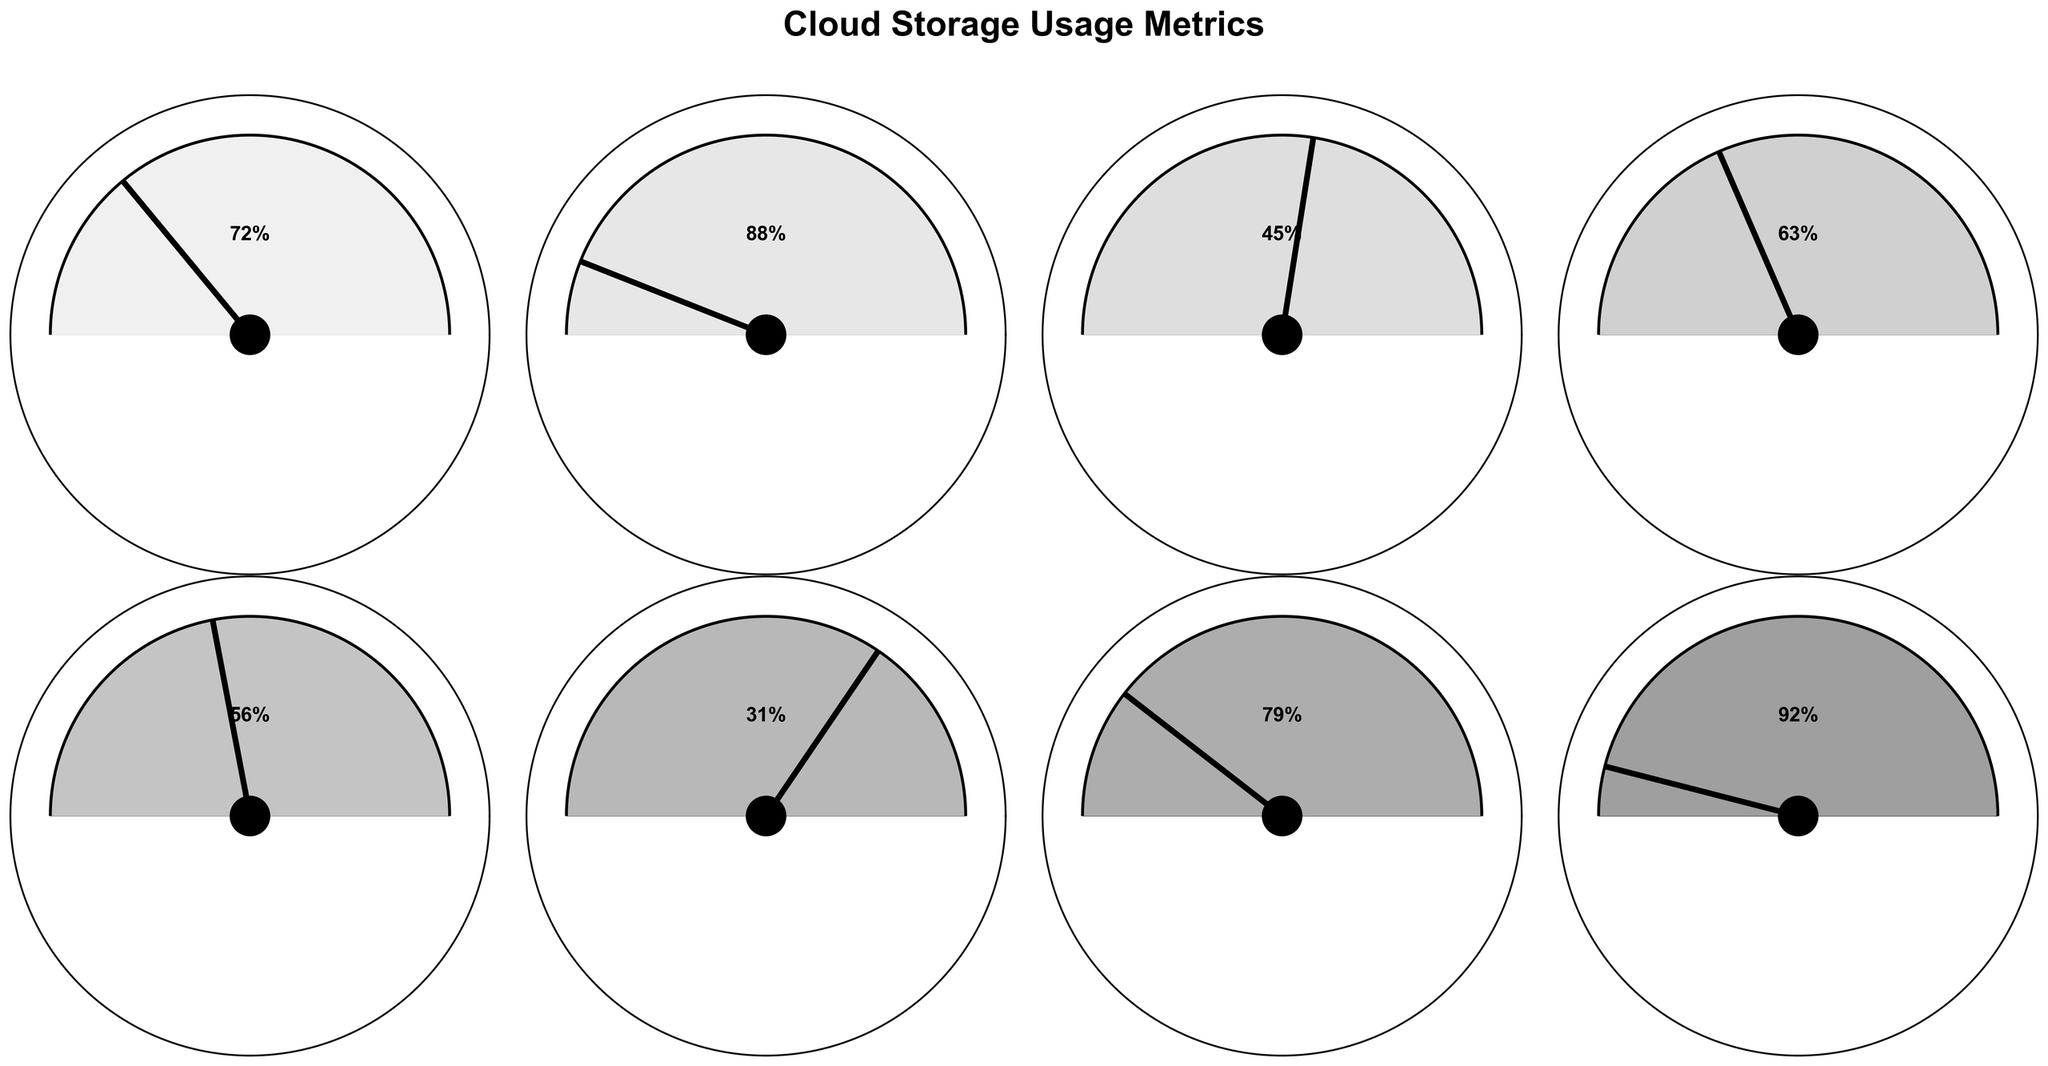Which storage tier has the highest percentage filled? The gauge chart for each storage tier shows different percentage values. The storage tier with the highest percentage filled is Google Cloud Filestore Enterprise with 92%.
Answer: Google Cloud Filestore Enterprise What is the percentage filled for AWS Glacier Deep Archive? Look at the gauge chart for AWS Glacier Deep Archive which shows the percentage filled. The percentage is displayed inside the gauge chart, which is 31%.
Answer: 31% Calculate the average percentage filled across all cloud storage tiers. Add all the percentage values: 72 + 88 + 45 + 63 + 56 + 31 + 79 + 92 = 526. Then, divide by the number of storage tiers, which is 8. 526 / 8 = 65.75%
Answer: 65.75% Which storage tier has a lower percentage filled, Azure Blob Cool or Google Cloud Storage Nearline? Compare the percentages filled for Azure Blob Cool and Google Cloud Storage Nearline. Azure Blob Cool is filled to 63%, and Google Cloud Storage Nearline is filled to 56%. Therefore, Google Cloud Storage Nearline has a lower percentage.
Answer: Google Cloud Storage Nearline How many storage tiers have a percentage filled greater than 70%? Count the number of storage tiers with more than 70% filled: S3 Standard (72%), EBS General Purpose SSD (gp3) (88%), Azure Data Lake Storage Gen2 (79%), and Google Cloud Filestore Enterprise (92%). There are 4 such storage tiers.
Answer: 4 What is the difference in percentage filled between EFS Standard and Azure Blob Cool? Subtract the percentage filled for EFS Standard from that of Azure Blob Cool: 63% (Azure Blob Cool) - 45% (EFS Standard) = 18%.
Answer: 18% Which storage tier has a percentage filled closest to 50%? Compare the percentages filled to find the one closest to 50%. EFS Standard is 45% filled, which is closest to 50%.
Answer: EFS Standard Are there any storage tiers with a percentage filled below 40%? Check the percentages filled for each storage tier and identify any below 40%. AWS Glacier Deep Archive is the only one with 31%, which is below 40%.
Answer: AWS Glacier Deep Archive 